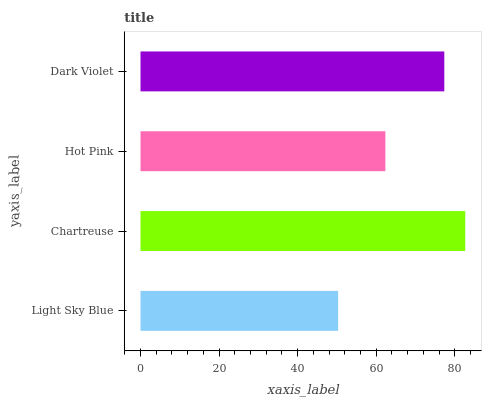Is Light Sky Blue the minimum?
Answer yes or no. Yes. Is Chartreuse the maximum?
Answer yes or no. Yes. Is Hot Pink the minimum?
Answer yes or no. No. Is Hot Pink the maximum?
Answer yes or no. No. Is Chartreuse greater than Hot Pink?
Answer yes or no. Yes. Is Hot Pink less than Chartreuse?
Answer yes or no. Yes. Is Hot Pink greater than Chartreuse?
Answer yes or no. No. Is Chartreuse less than Hot Pink?
Answer yes or no. No. Is Dark Violet the high median?
Answer yes or no. Yes. Is Hot Pink the low median?
Answer yes or no. Yes. Is Hot Pink the high median?
Answer yes or no. No. Is Dark Violet the low median?
Answer yes or no. No. 